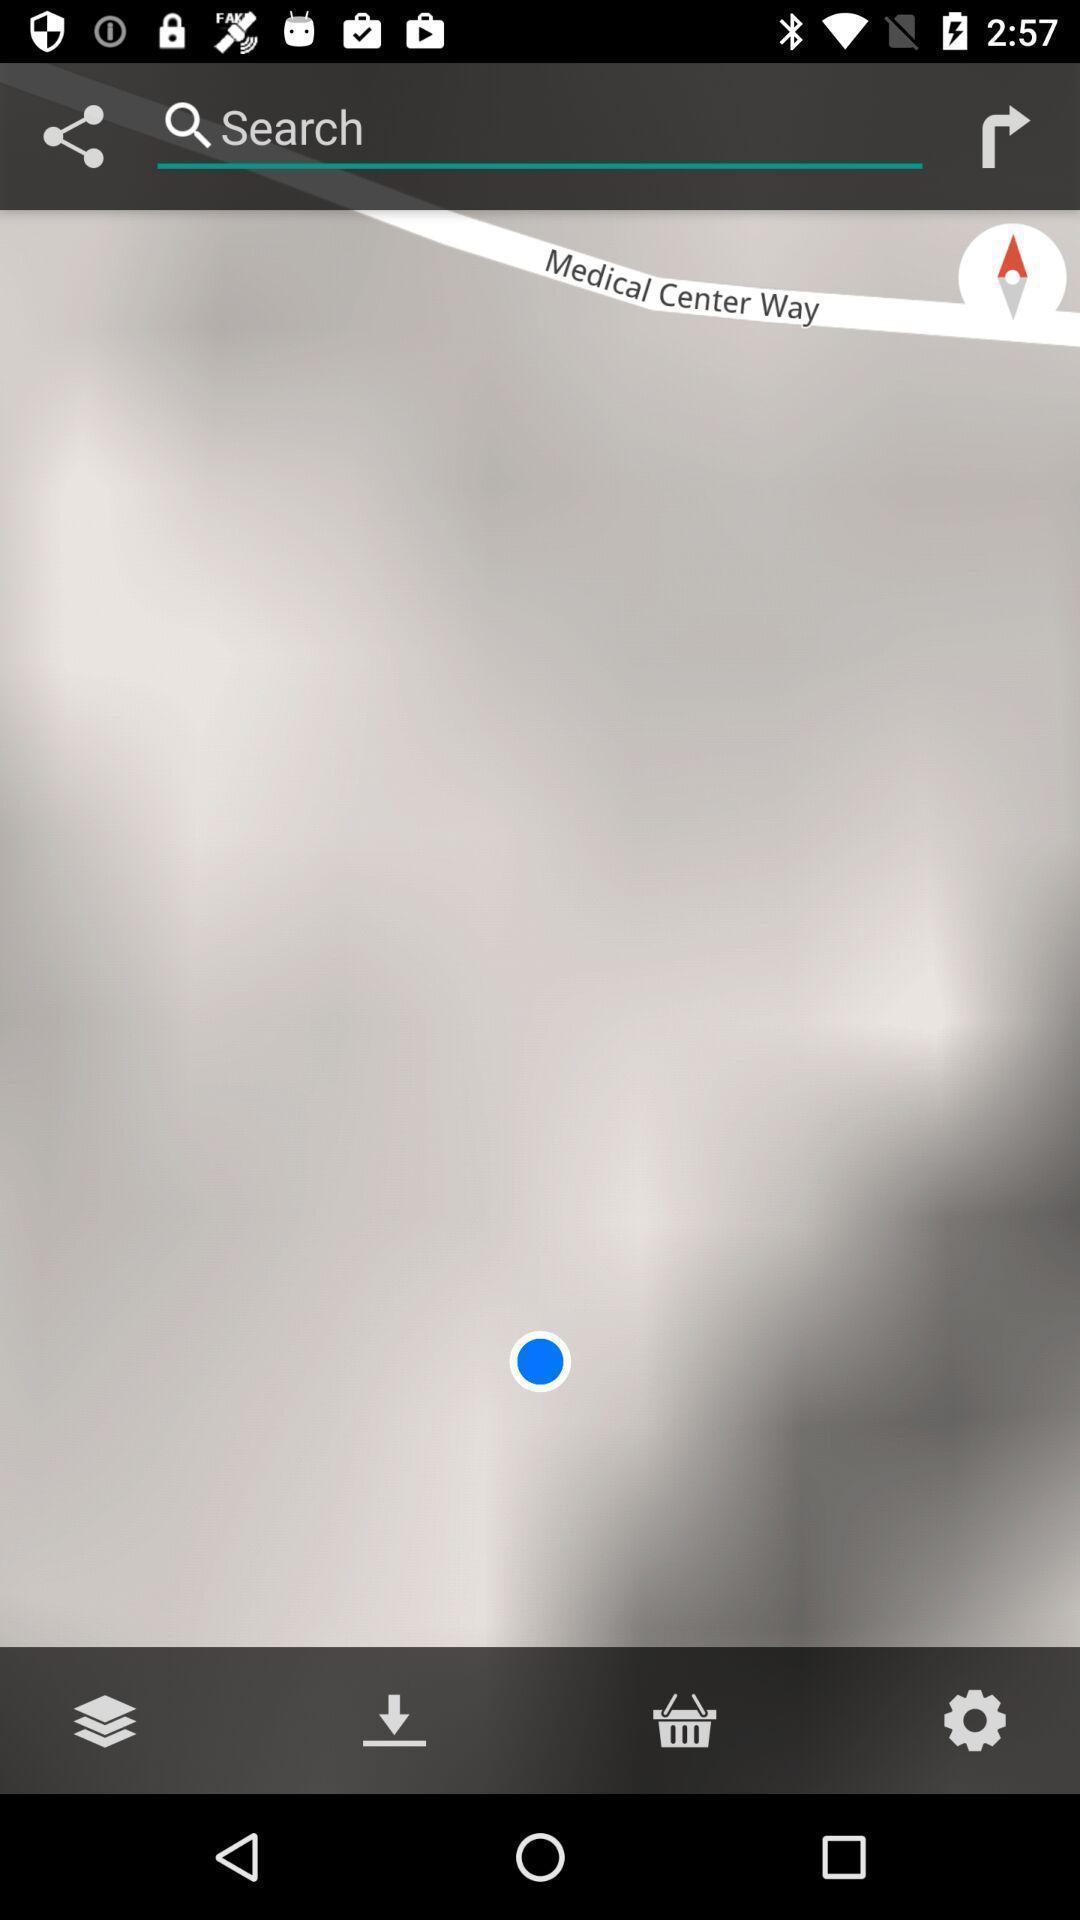Summarize the main components in this picture. Search page of a location finder app. 